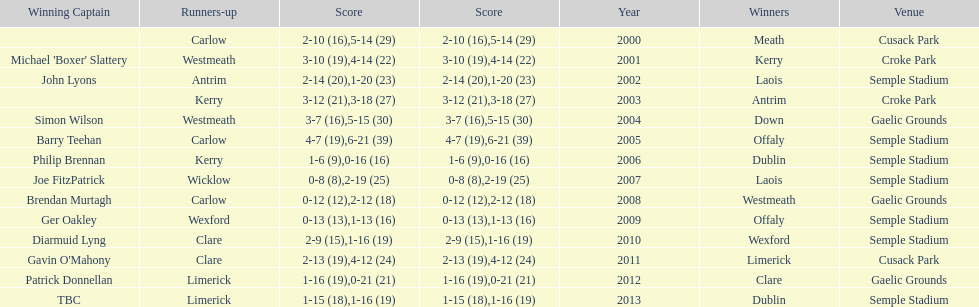Who was the first winning captain? Michael 'Boxer' Slattery. 